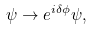<formula> <loc_0><loc_0><loc_500><loc_500>\psi \rightarrow e ^ { i \delta \phi } \psi ,</formula> 